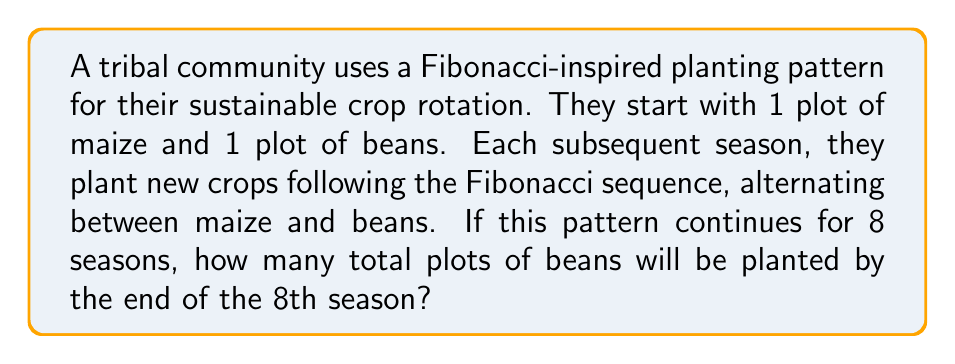Help me with this question. Let's approach this step-by-step:

1) The Fibonacci sequence starts with 1, 1 and each subsequent number is the sum of the two preceding ones.

2) Let's list out the number of plots for each season, alternating between maize (M) and beans (B):
   Season 1: 1M
   Season 2: 1B
   Season 3: 2M
   Season 4: 3B
   Season 5: 5M
   Season 6: 8B
   Season 7: 13M
   Season 8: 21B

3) We're interested in the total number of bean plots. These occur in even-numbered seasons.

4) To calculate the total, we sum the bean plots:
   $$ \text{Total Bean Plots} = 1 + 3 + 8 + 21 $$

5) Calculating this sum:
   $$ \text{Total Bean Plots} = 33 $$

Thus, by the end of the 8th season, there will be a total of 33 plots of beans planted.
Answer: 33 